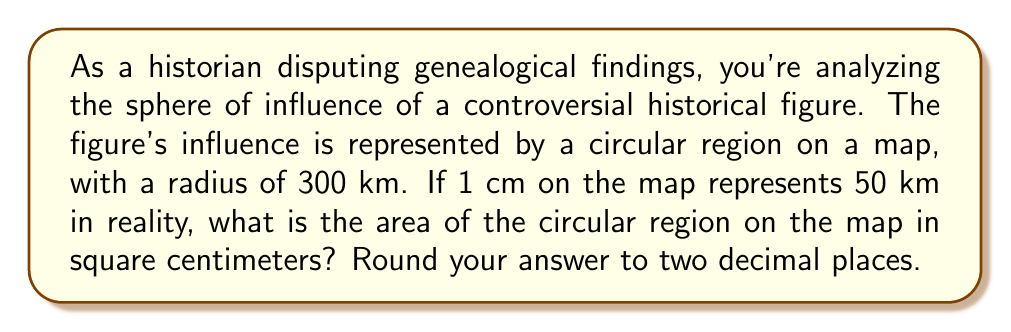Provide a solution to this math problem. Let's approach this step-by-step:

1) First, we need to convert the actual radius to the radius on the map:
   $$ \text{Map radius} = \frac{300 \text{ km}}{50 \text{ km/cm}} = 6 \text{ cm} $$

2) Now that we have the radius on the map, we can use the formula for the area of a circle:
   $$ A = \pi r^2 $$
   Where $A$ is the area and $r$ is the radius.

3) Substituting our radius of 6 cm:
   $$ A = \pi (6 \text{ cm})^2 = 36\pi \text{ cm}^2 $$

4) Calculate this value:
   $$ A = 36 \times 3.14159... = 113.09734... \text{ cm}^2 $$

5) Rounding to two decimal places:
   $$ A \approx 113.10 \text{ cm}^2 $$

This area represents the sphere of influence of the historical figure on the map.
Answer: $113.10 \text{ cm}^2$ 